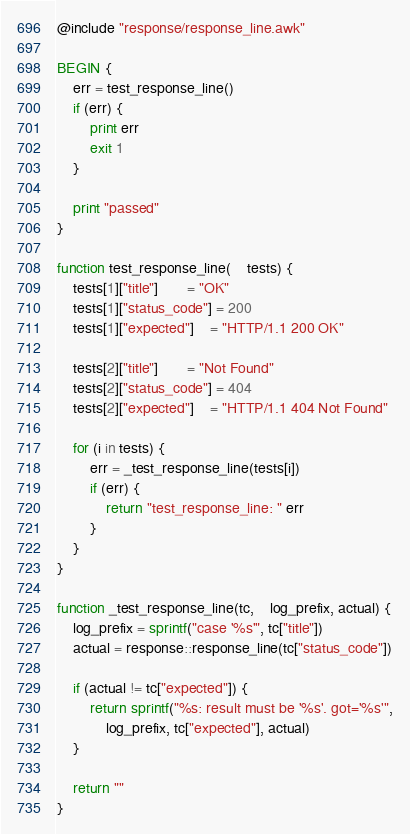<code> <loc_0><loc_0><loc_500><loc_500><_Awk_>@include "response/response_line.awk"

BEGIN {
    err = test_response_line()
    if (err) {
        print err
        exit 1
    }

    print "passed"
}

function test_response_line(    tests) {
    tests[1]["title"]       = "OK"
    tests[1]["status_code"] = 200
    tests[1]["expected"]    = "HTTP/1.1 200 OK"

    tests[2]["title"]       = "Not Found"
    tests[2]["status_code"] = 404
    tests[2]["expected"]    = "HTTP/1.1 404 Not Found"

    for (i in tests) {
        err = _test_response_line(tests[i])
        if (err) {
            return "test_response_line: " err
        }
    }
}

function _test_response_line(tc,    log_prefix, actual) {
    log_prefix = sprintf("case '%s'", tc["title"])
    actual = response::response_line(tc["status_code"])

    if (actual != tc["expected"]) {
        return sprintf("%s: result must be '%s'. got='%s'",
            log_prefix, tc["expected"], actual)
    }

    return ""
}
</code> 